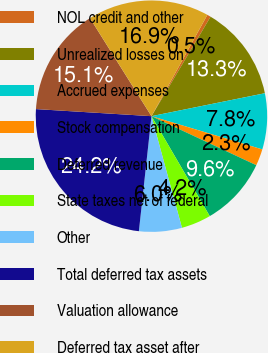<chart> <loc_0><loc_0><loc_500><loc_500><pie_chart><fcel>NOL credit and other<fcel>Unrealized losses on<fcel>Accrued expenses<fcel>Stock compensation<fcel>Deferred revenue<fcel>State taxes net of federal<fcel>Other<fcel>Total deferred tax assets<fcel>Valuation allowance<fcel>Deferred tax asset after<nl><fcel>0.51%<fcel>13.29%<fcel>7.81%<fcel>2.33%<fcel>9.63%<fcel>4.16%<fcel>5.98%<fcel>24.24%<fcel>15.11%<fcel>16.94%<nl></chart> 